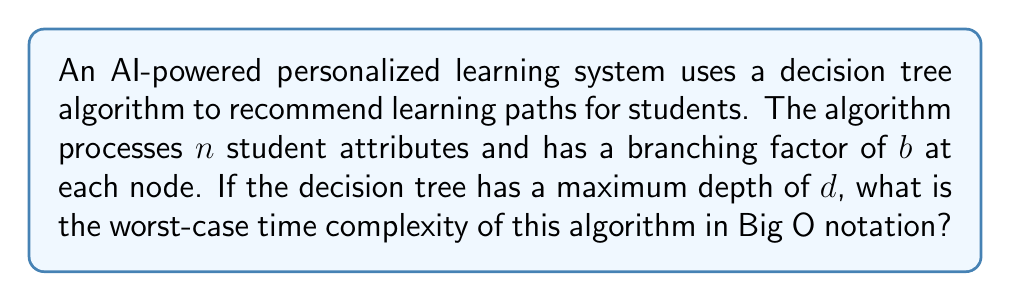Show me your answer to this math problem. To analyze the time complexity of this decision tree algorithm, we need to consider the following steps:

1. The algorithm processes $n$ student attributes, which means it needs to examine all of these attributes in the worst case.

2. At each node of the decision tree, the algorithm makes a decision based on one of these attributes, with a branching factor of $b$. This means that at each level, the number of potential paths increases by a factor of $b$.

3. The maximum depth of the tree is $d$, which represents the longest path from the root to a leaf node.

To determine the worst-case time complexity:

1. At each level, the algorithm may need to examine up to $b$ branches.
2. There are $d$ levels in total.
3. At each node, the algorithm needs to process at least one of the $n$ attributes.

Therefore, the total number of operations in the worst case can be expressed as:

$$ O(n \cdot b^d) $$

This is because:
- The algorithm examines $n$ attributes at each node.
- There are potentially $b^d$ nodes in the worst case (when the tree is full and balanced).

It's worth noting that this is an upper bound on the time complexity. In practice, the algorithm might not always reach the maximum depth for all branches, and some attributes might be used multiple times along a path, potentially reducing the effective number of attributes examined at deeper levels.

For an educational administrator, this analysis is crucial for understanding the scalability of the AI system as the number of student attributes or the complexity of the decision tree increases. It can help in resource allocation and system optimization decisions.
Answer: $O(n \cdot b^d)$ 